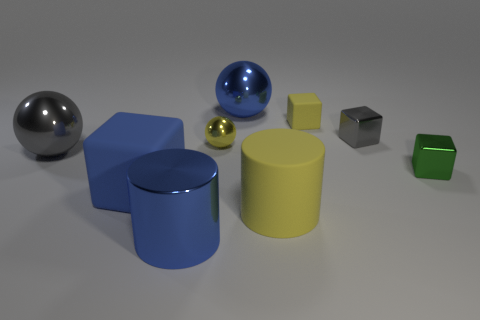Subtract all big shiny balls. How many balls are left? 1 Add 1 blue metal spheres. How many objects exist? 10 Subtract 2 cubes. How many cubes are left? 2 Subtract all gray blocks. How many blocks are left? 3 Subtract all blocks. How many objects are left? 5 Subtract 0 cyan cylinders. How many objects are left? 9 Subtract all cyan cubes. Subtract all green cylinders. How many cubes are left? 4 Subtract all green balls. How many green cubes are left? 1 Subtract all large blue metallic things. Subtract all large yellow cylinders. How many objects are left? 6 Add 9 big blue matte cubes. How many big blue matte cubes are left? 10 